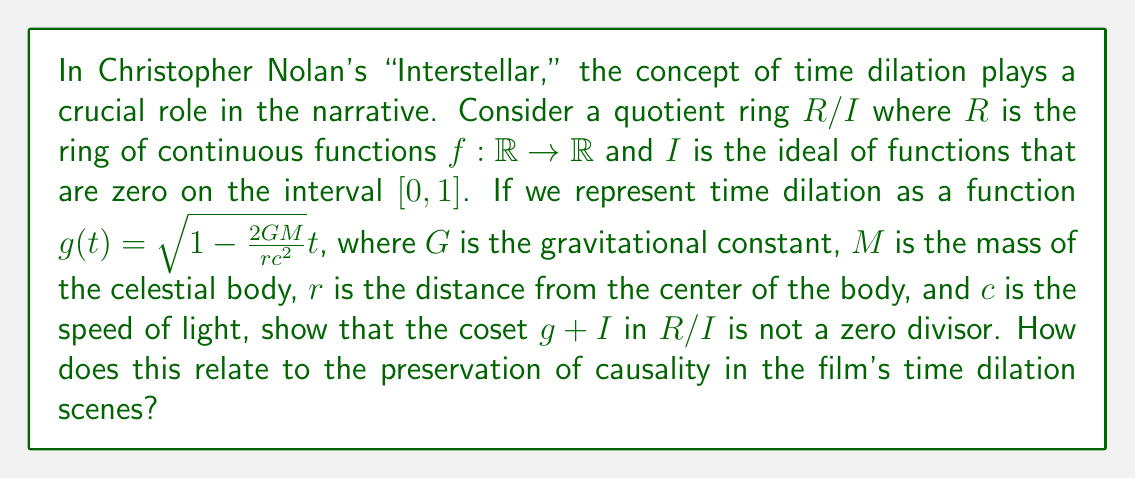Give your solution to this math problem. To solve this problem, we need to follow these steps:

1) First, let's recall that an element $a$ in a ring is a zero divisor if there exists a non-zero element $b$ such that $ab = 0$ or $ba = 0$.

2) In our quotient ring $R/I$, we need to show that for any non-zero coset $f + I$, the product $(g + I)(f + I)$ is not equal to the zero coset $I$.

3) The product $(g + I)(f + I)$ is equal to $gf + I$. So, we need to show that $gf$ is not in $I$ for any non-zero $f + I$.

4) Suppose $f + I$ is non-zero. This means that $f$ is not in $I$, so there exists some $t_0 \in [0, 1]$ such that $f(t_0) \neq 0$.

5) Now, let's look at the time dilation function $g(t) = \sqrt{1 - \frac{2GM}{rc^2}}t$. This function is always positive for $t > 0$ (assuming $r > \frac{2GM}{c^2}$, which is true for any point outside the event horizon of a black hole).

6) Therefore, $g(t_0) > 0$ for our $t_0 \in [0, 1]$.

7) Now, $(gf)(t_0) = g(t_0)f(t_0) \neq 0$ because both $g(t_0)$ and $f(t_0)$ are non-zero.

8) This means that $gf$ is not in $I$, because it's non-zero at a point in $[0, 1]$.

9) Therefore, $(g + I)(f + I) = gf + I \neq I$ for any non-zero $f + I$.

This mathematical property relates to the preservation of causality in "Interstellar" because it shows that time dilation, represented by $g$, doesn't "annihilate" any non-zero time intervals. In the film, while time passes at different rates for different characters, cause and effect are still preserved, and no events are erased or reversed. This is similar to how $g + I$ doesn't make any non-zero coset $f + I$ become zero in our quotient ring.
Answer: The coset $g + I$ is not a zero divisor in $R/I$ because for any non-zero coset $f + I$, the product $(g + I)(f + I) = gf + I \neq I$. This reflects the preservation of causality in "Interstellar," where time dilation affects the rate of time passage but doesn't erase or reverse events. 